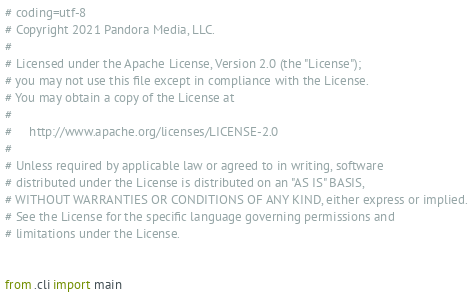<code> <loc_0><loc_0><loc_500><loc_500><_Python_># coding=utf-8
# Copyright 2021 Pandora Media, LLC.
#
# Licensed under the Apache License, Version 2.0 (the "License");
# you may not use this file except in compliance with the License.
# You may obtain a copy of the License at
#
#     http://www.apache.org/licenses/LICENSE-2.0
#
# Unless required by applicable law or agreed to in writing, software
# distributed under the License is distributed on an "AS IS" BASIS,
# WITHOUT WARRANTIES OR CONDITIONS OF ANY KIND, either express or implied.
# See the License for the specific language governing permissions and
# limitations under the License.


from .cli import main
</code> 